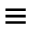<formula> <loc_0><loc_0><loc_500><loc_500>\equiv</formula> 